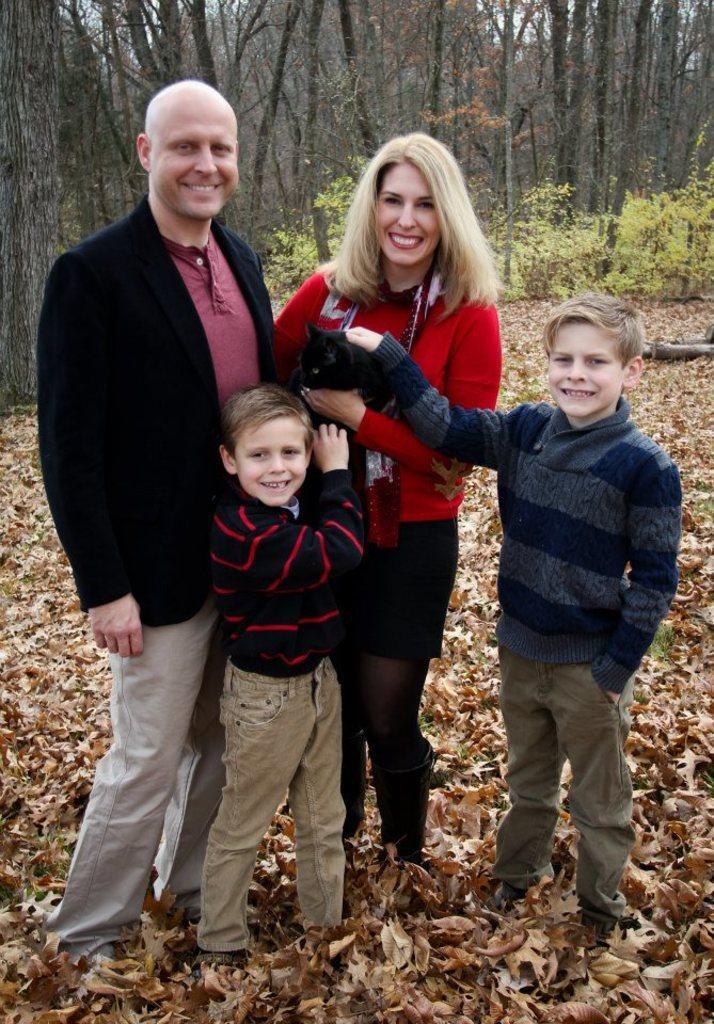Can you describe this image briefly? In the image we can see there are four people men, women and two boys an they are catching a cat. There are many trees, plants and dry leaves. 